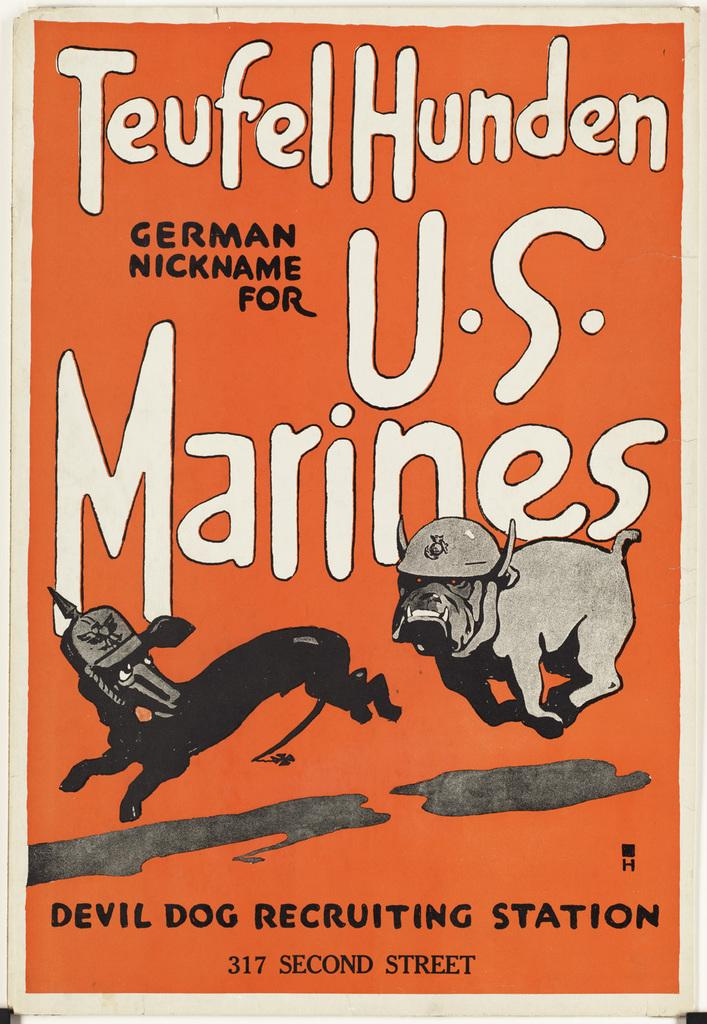What type of visual is the image? The image is a poster. What can be seen in the pictures on the poster? There are pictures of animals on the poster. What else is featured on the poster besides the images? There is text written on the poster. What type of band is performing in the image? There is no band present in the image; it features a poster with pictures of animals and text. What activity can be seen involving a ray in the image? There is no ray or any activity involving a ray in the image; it only contains pictures of animals and text. 